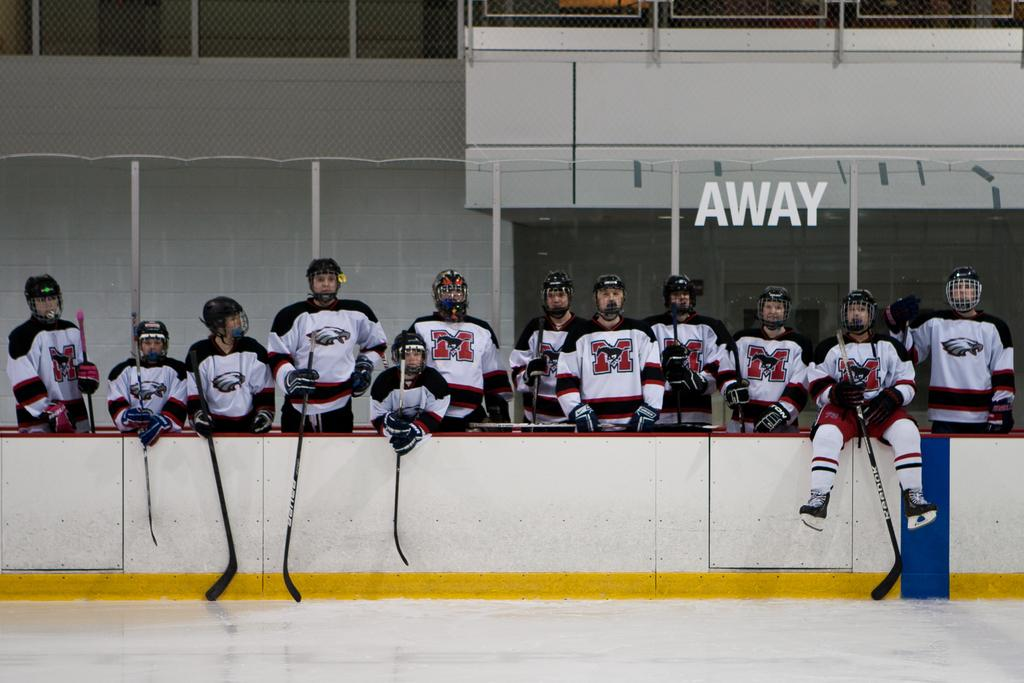Provide a one-sentence caption for the provided image. A member of the away team sits on the wall around the ice rink. 